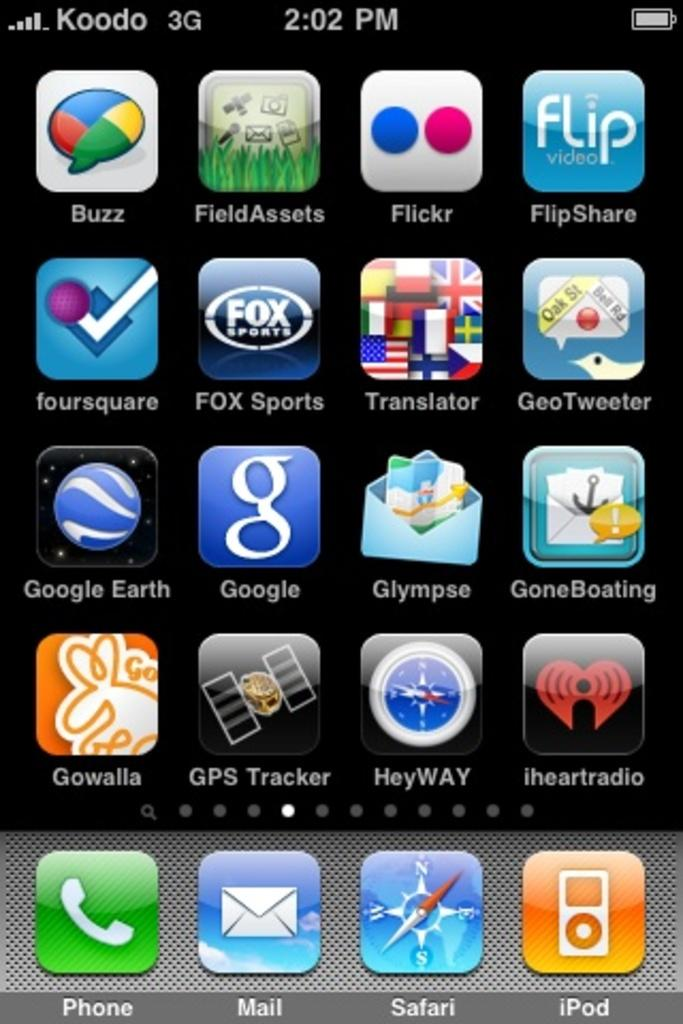Provide a one-sentence caption for the provided image. The iPhone has many apps such as Google Earth and Safari. 